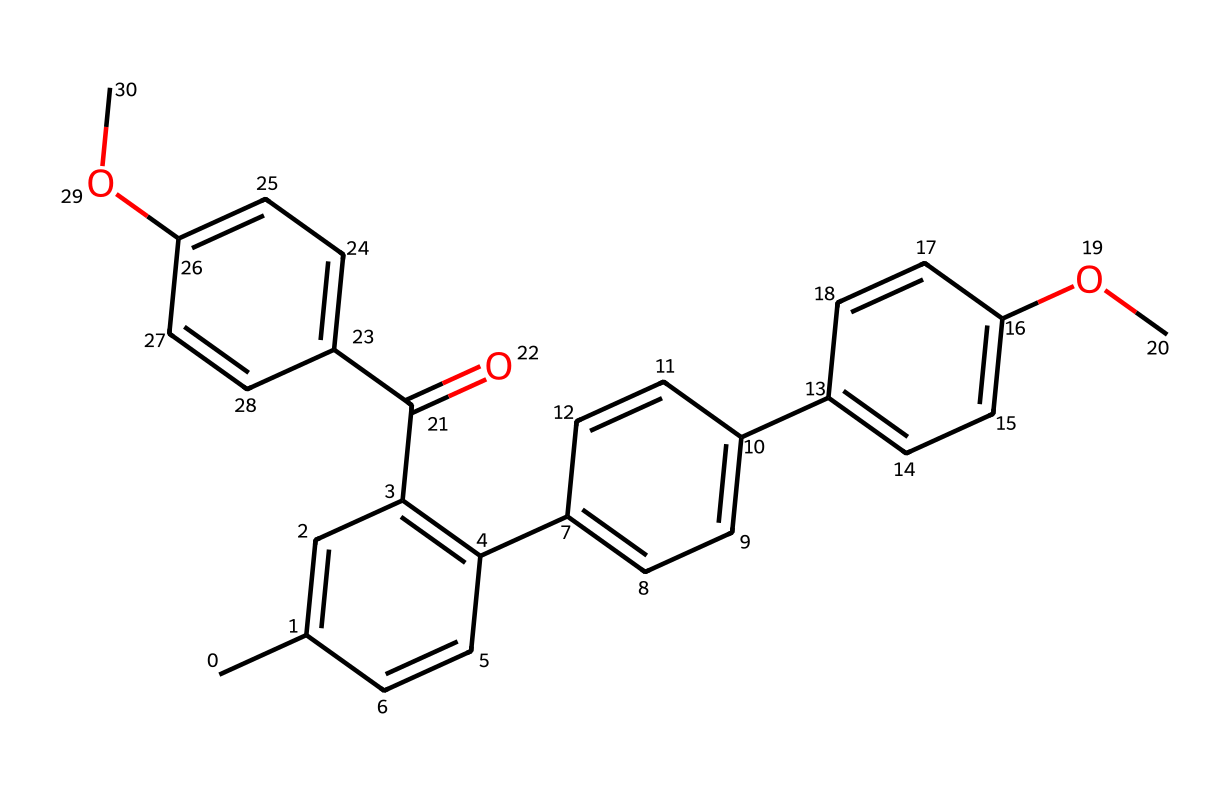What is the molecular formula of this compound? To determine the molecular formula, we identify the individual atoms in the SMILES representation. Counting the number of carbon (C), hydrogen (H), and oxygen (O) atoms gives us 22 carbons, 18 hydrogens, and 4 oxygens. Therefore, the molecular formula is C22H18O4.
Answer: C22H18O4 How many rings are present in this structure? By analyzing the chemical structure suggested by the SMILES, we can see that it has four interconnected aromatic rings. Each aromatic ring is distinct and contributes to the overall structure.
Answer: 4 What functional groups are present in the molecule? The structure contains ether (-O-), carbonyl (C=O), and methoxy (-OCH3) functional groups. These groups can be identified by their specific atom arrangements, indicative of their characteristics.
Answer: ether, carbonyl, methoxy Which part of this molecule contributes to light absorption? The conjugated system of carbon-carbon double bonds found in the aromatic rings allows for light absorption due to π-electron delocalization. The presence of multiple overlapping pi bonds enables resonance, absorbing specific wavelengths of light.
Answer: conjugated system What type of chemical compound is this? The presence of multiple phenolic structures and its ability to absorb light indicates that this compound is a photoreactive compound, specifically a blue light filter. The structure is designed to interact with and absorb light effectively.
Answer: photoreactive compound Does this compound have a symmetrical structure? Evaluating the arrangement of its rings and substituents shows that the molecule exhibits a level of symmetry due to the arrangement of identical aromatic rings on either side. Each side is a mirror reflection of the other, contributing to the symmetry.
Answer: yes 